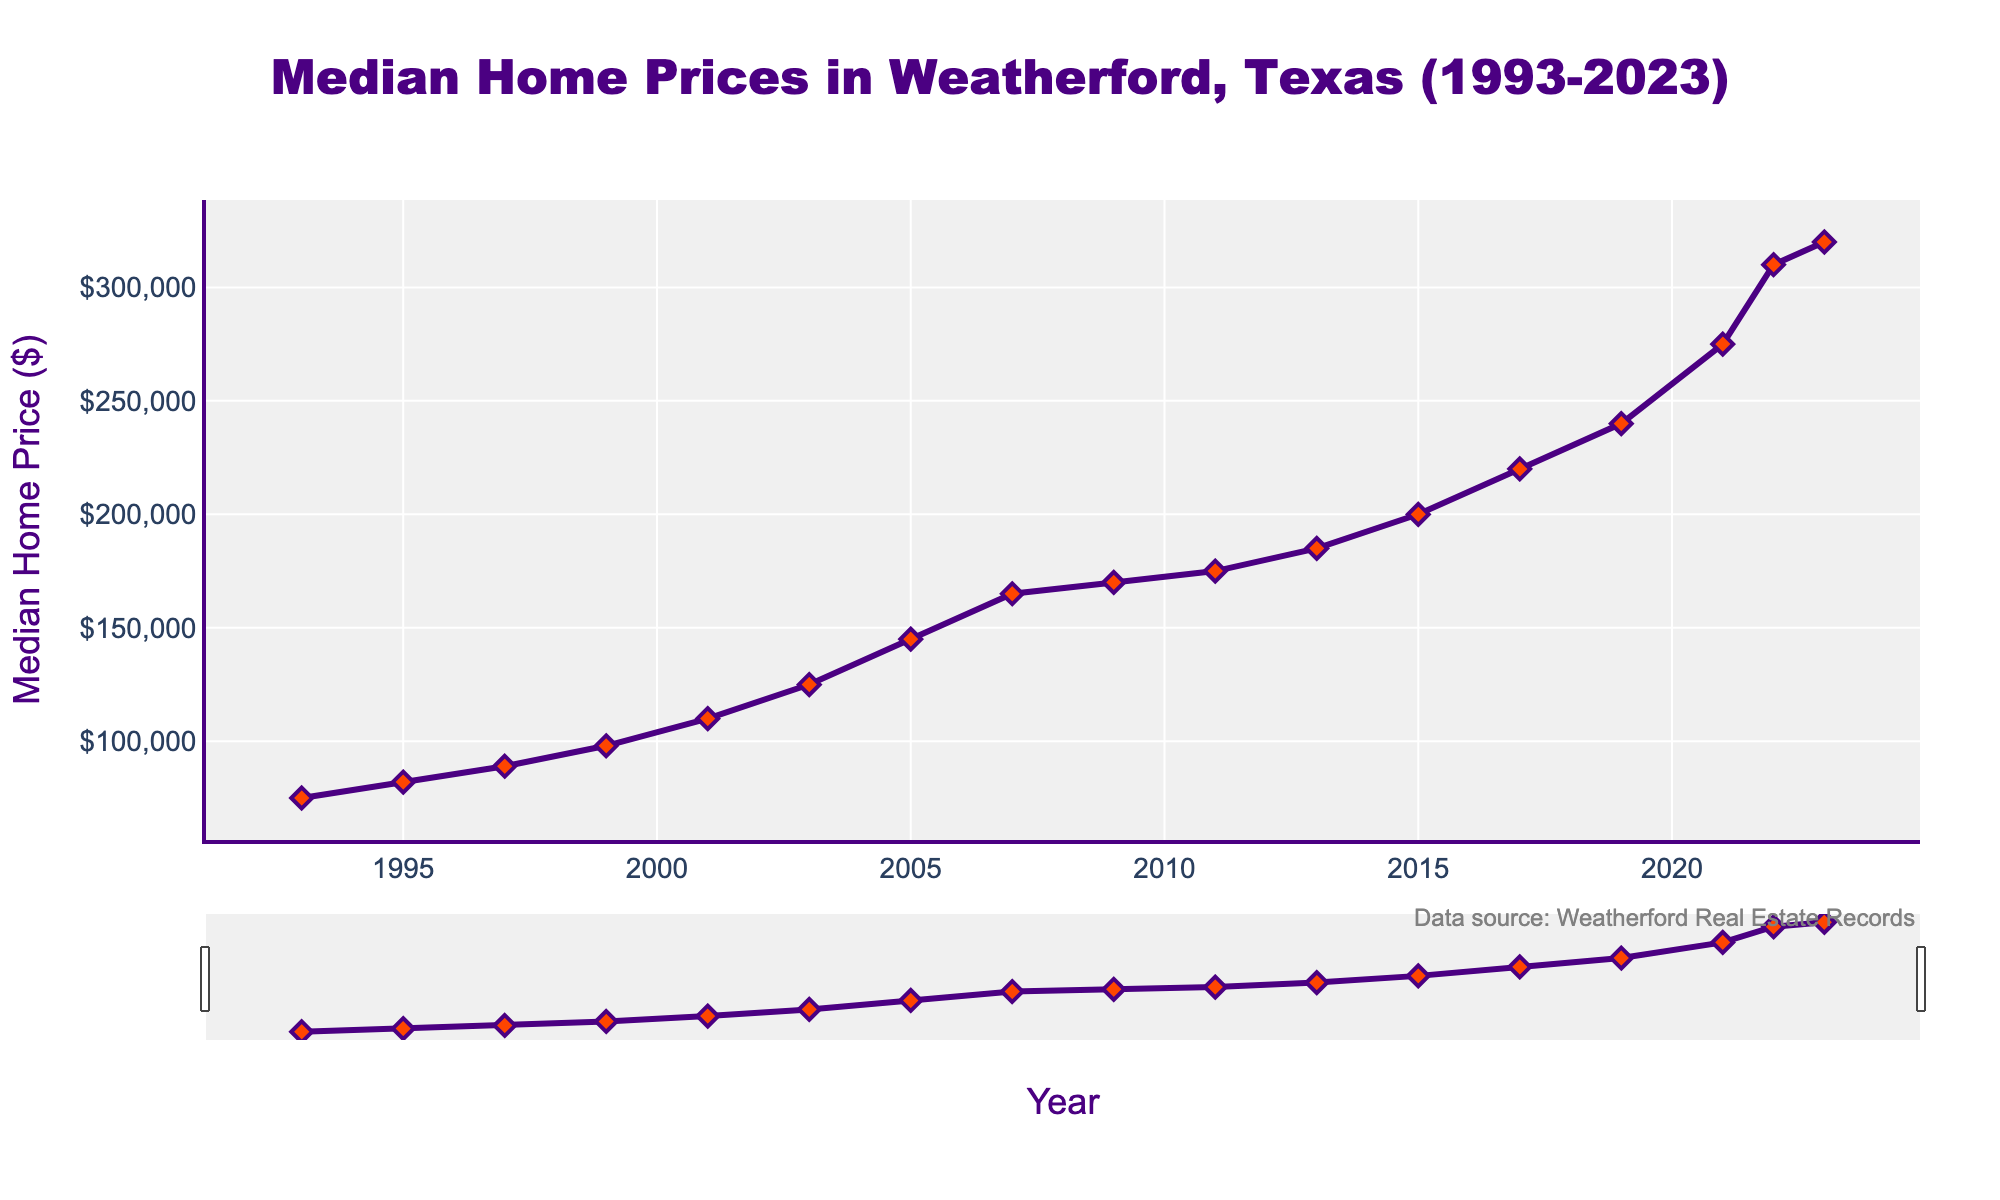What was the median home price in 1993? Refer to the data point for the year 1993 directly on the plot.
Answer: 75000 How much did the median home price increase between 1995 and 1999? Find the home price in 1995 (82000) and in 1999 (98000), then subtract to find the difference: 98000 - 82000.
Answer: 16000 In which year did the median home price first reach 200000? Look for the first data point where the home price hits or exceeds 200000, which is in 2015.
Answer: 2015 By how much did the median home price increase from 2001 to 2023? Subtract the median home price in 2001 (110000) from the price in 2023 (320000): 320000 - 110000.
Answer: 210000 What is the percentage increase in median home price from 2019 to 2023? First, find the difference in the home prices between 2019 (240000) and 2023 (320000). Then, calculate the percentage increase using the formula: [(320000 - 240000) / 240000] * 100.
Answer: 33.33% Which year experienced the highest change in median home price compared to the previous year? Scan through the yearly differences, noticing the largest spike is from 2021 (275000) to 2022 (310000).
Answer: 2022 How much did the median home price increase during the 2000s decade (2000-2009)? Find the median home price in 2000 and 2009. Since we lack a data point for 2000, approximate using 2001 (110000) and 2009 (170000), then subtract: 170000 - 110000.
Answer: 60000 In the 1990s, which year saw the most significant rise in home prices? Compare the increments of prices between 1993, 1995, 1997, and 1999. The largest increase is from 1997 to 1999.
Answer: 1999 What was the average median home price between 2011 and 2019? Add the home prices for the years 2011, 2013, 2015, 2017, and 2019, then divide by 5: (175000 + 185000 + 200000 + 220000 + 240000) / 5.
Answer: 204000 